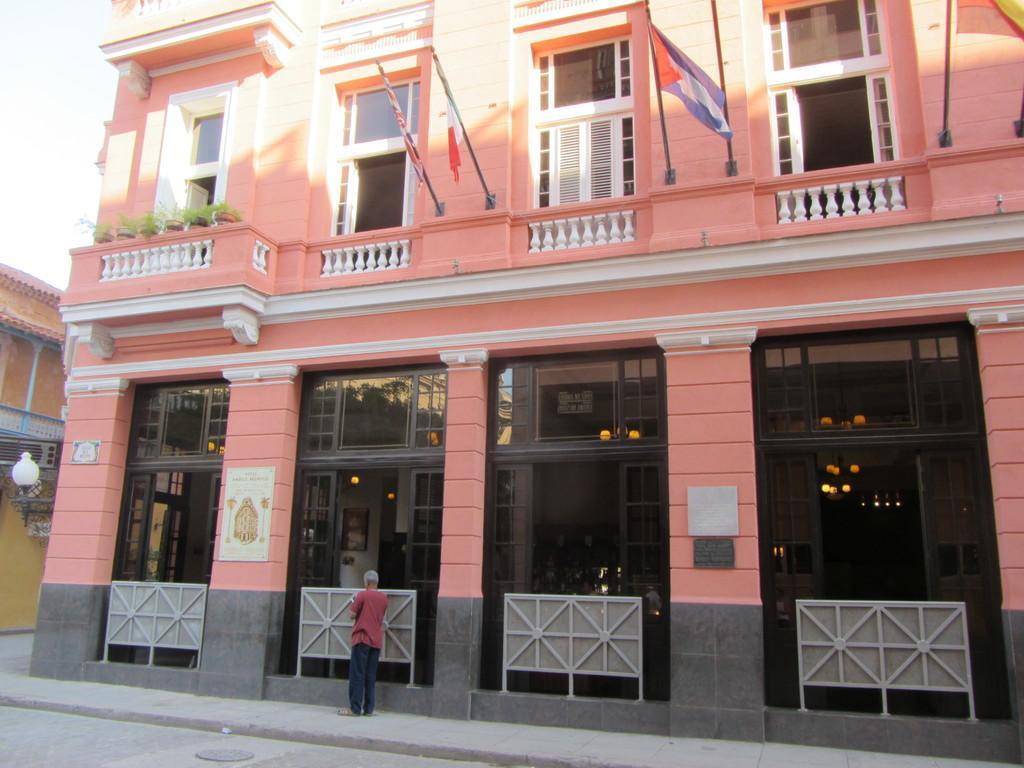Can you describe this image briefly? Building with windows. Here we can see a person, plants and flags. Light is attached to this building. 